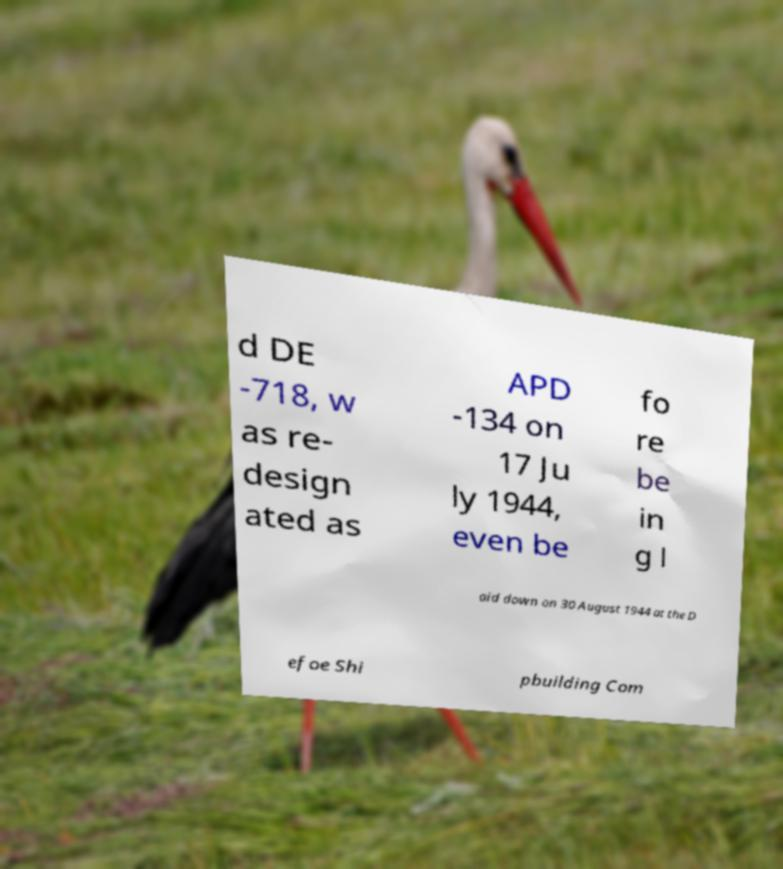Could you assist in decoding the text presented in this image and type it out clearly? d DE -718, w as re- design ated as APD -134 on 17 Ju ly 1944, even be fo re be in g l aid down on 30 August 1944 at the D efoe Shi pbuilding Com 